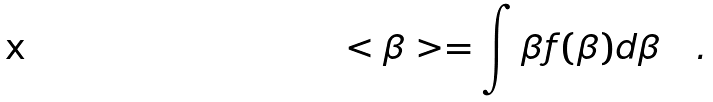<formula> <loc_0><loc_0><loc_500><loc_500>< \beta > = \int \beta f ( \beta ) d \beta \quad .</formula> 